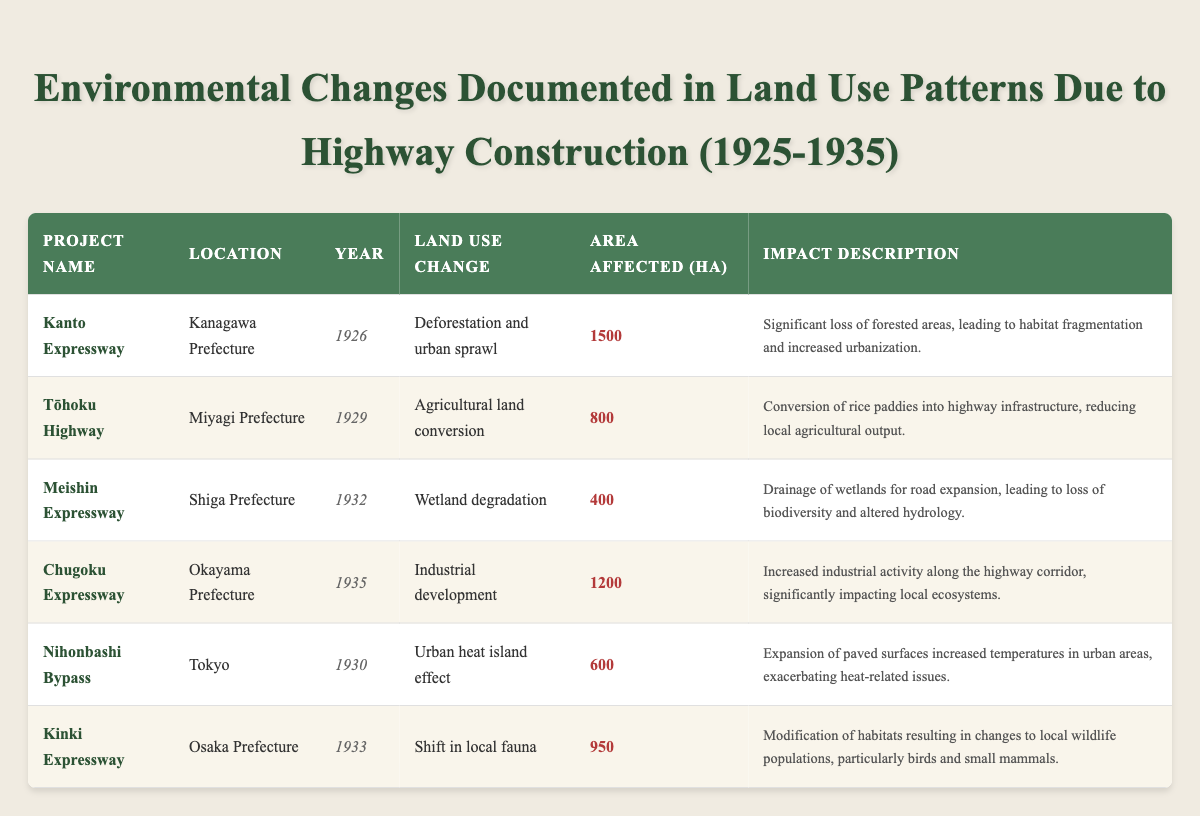What is the total area affected by the Kanto Expressway project? The area affected by the Kanto Expressway is listed as 1500 hectares in the table.
Answer: 1500 hectares Which project had the least area affected? The Meishin Expressway project had the least area affected at 400 hectares.
Answer: 400 hectares Is the Tōhoku Highway project associated with urban sprawl? No, the Tōhoku Highway project is associated with agricultural land conversion, not urban sprawl.
Answer: No Calculate the total area affected by the Chugoku Expressway and Kinki Expressway. The Chugoku Expressway affects 1200 hectares and Kinki Expressway affects 950 hectares. Adding them together gives 1200 + 950 = 2150 hectares.
Answer: 2150 hectares Which project took place in Tokyo? The Nihonbashi Bypass is the project that took place in Tokyo.
Answer: Nihonbashi Bypass What type of land use change occurred due to the Meishin Expressway? The Meishin Expressway resulted in wetland degradation as the type of land use change.
Answer: Wetland degradation How many projects resulted in deforestation or urban sprawl? Only one project, the Kanto Expressway, resulted in deforestation and urban sprawl.
Answer: 1 project What percentage of the total area affected was due to agricultural land conversion? First, sum the total area affected: 1500 + 800 + 400 + 1200 + 600 + 950 = 4550 hectares. The area affected by agricultural land conversion is 800 hectares. Calculate the percentage: (800 / 4550) * 100 = approximately 17.58%.
Answer: Approximately 17.58% Did any projects document changes to local wildlife populations? Yes, the Kinki Expressway documented a shift in local fauna, indicating changes to wildlife populations.
Answer: Yes Which type of land use change is linked to the largest affected area? Deforestation and urban sprawl linked to the Kanto Expressway is associated with the largest affected area of 1500 hectares.
Answer: Deforestation and urban sprawl Which year had the most projects documented for environmental change? The years 1930 and 1935 each had one project documented, while 1926, 1929, 1932, and 1933 had one project each, showing no year had multiple entries.
Answer: No year had multiple projects 